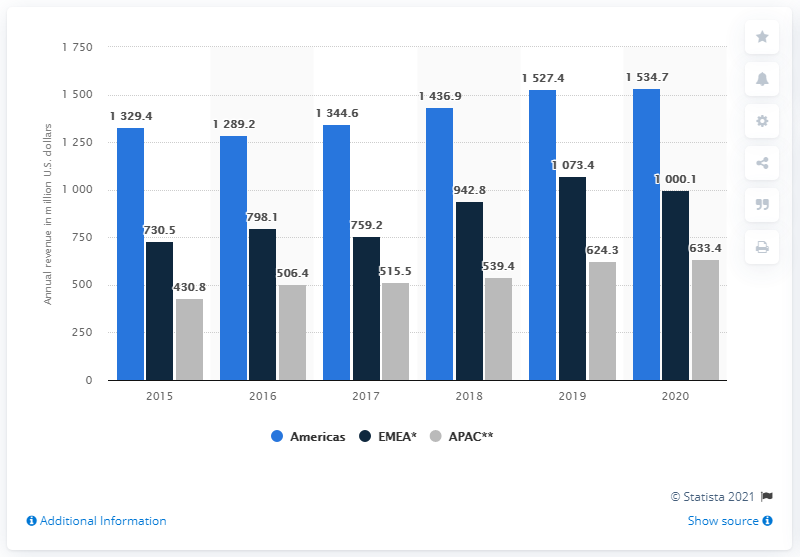Outline some significant characteristics in this image. In the fiscal year 2020, the Americas earned a total of 1534.7 billion dollars. The average annual revenue from the Americas from 2018 to 2020 was approximately $1,499.67. In 2016, the company's revenue in the Americas was $1,289.2 million. 